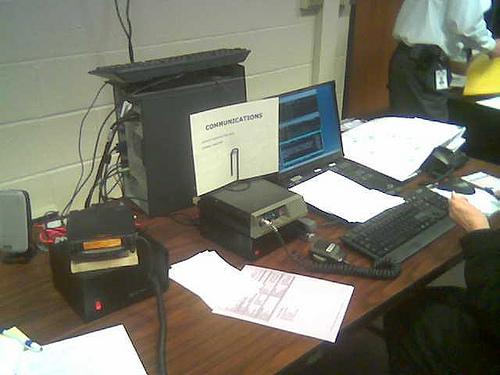Question: how is the desk made?
Choices:
A. Of wood.
B. Of pine.
C. Of oak.
D. Of composite materials.
Answer with the letter. Answer: A Question: what color is the desk?
Choices:
A. Black.
B. White.
C. Brown.
D. Yellow.
Answer with the letter. Answer: C Question: who is in the picture?
Choices:
A. Father and son.
B. Two people.
C. Grandmother and grandchild.
D. Husband and wife.
Answer with the letter. Answer: B Question: how is the keyboard made?
Choices:
A. Ivory.
B. Man-made materials.
C. Plastic.
D. Synthetic materials.
Answer with the letter. Answer: C Question: what is on the desk?
Choices:
A. A lamp.
B. A laptop.
C. A pen.
D. A notebook.
Answer with the letter. Answer: B 